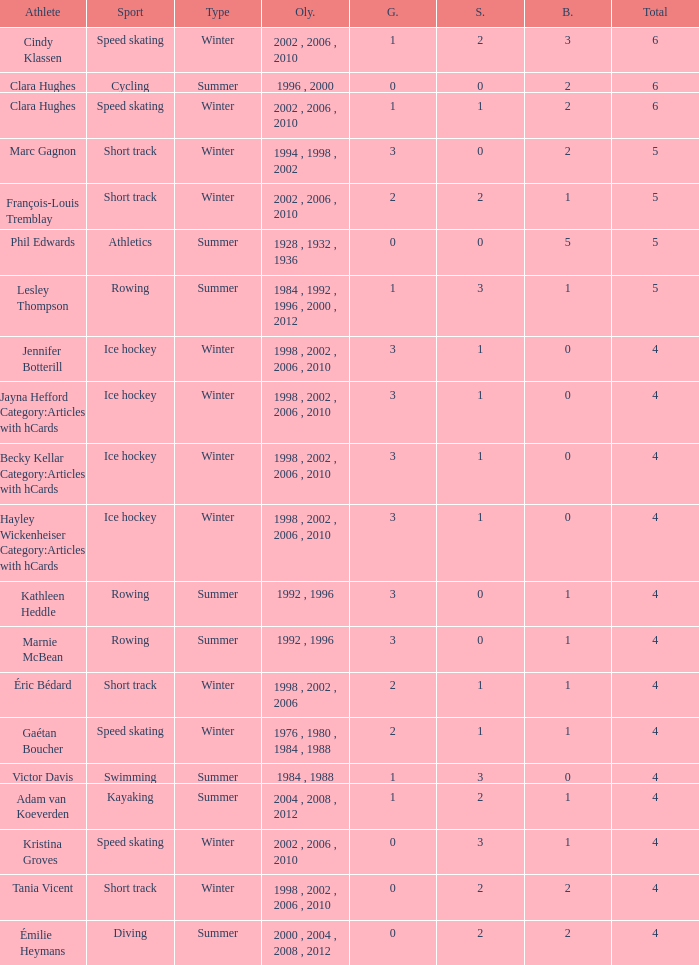What is the lowest number of bronze a short track athlete with 0 gold medals has? 2.0. 